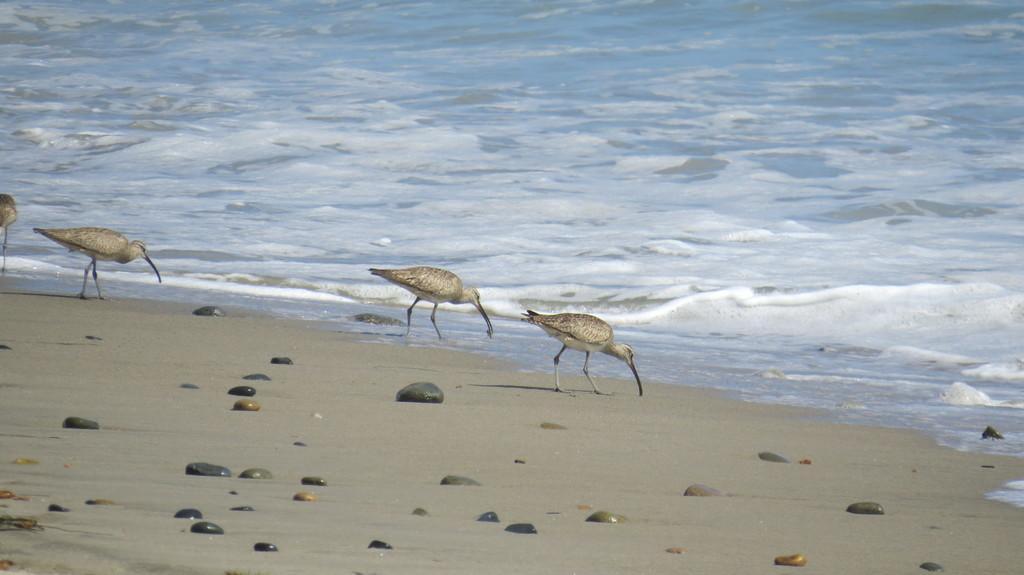Could you give a brief overview of what you see in this image? In this image few birds are standing on the land having few rocks. Background there is water having tides. 